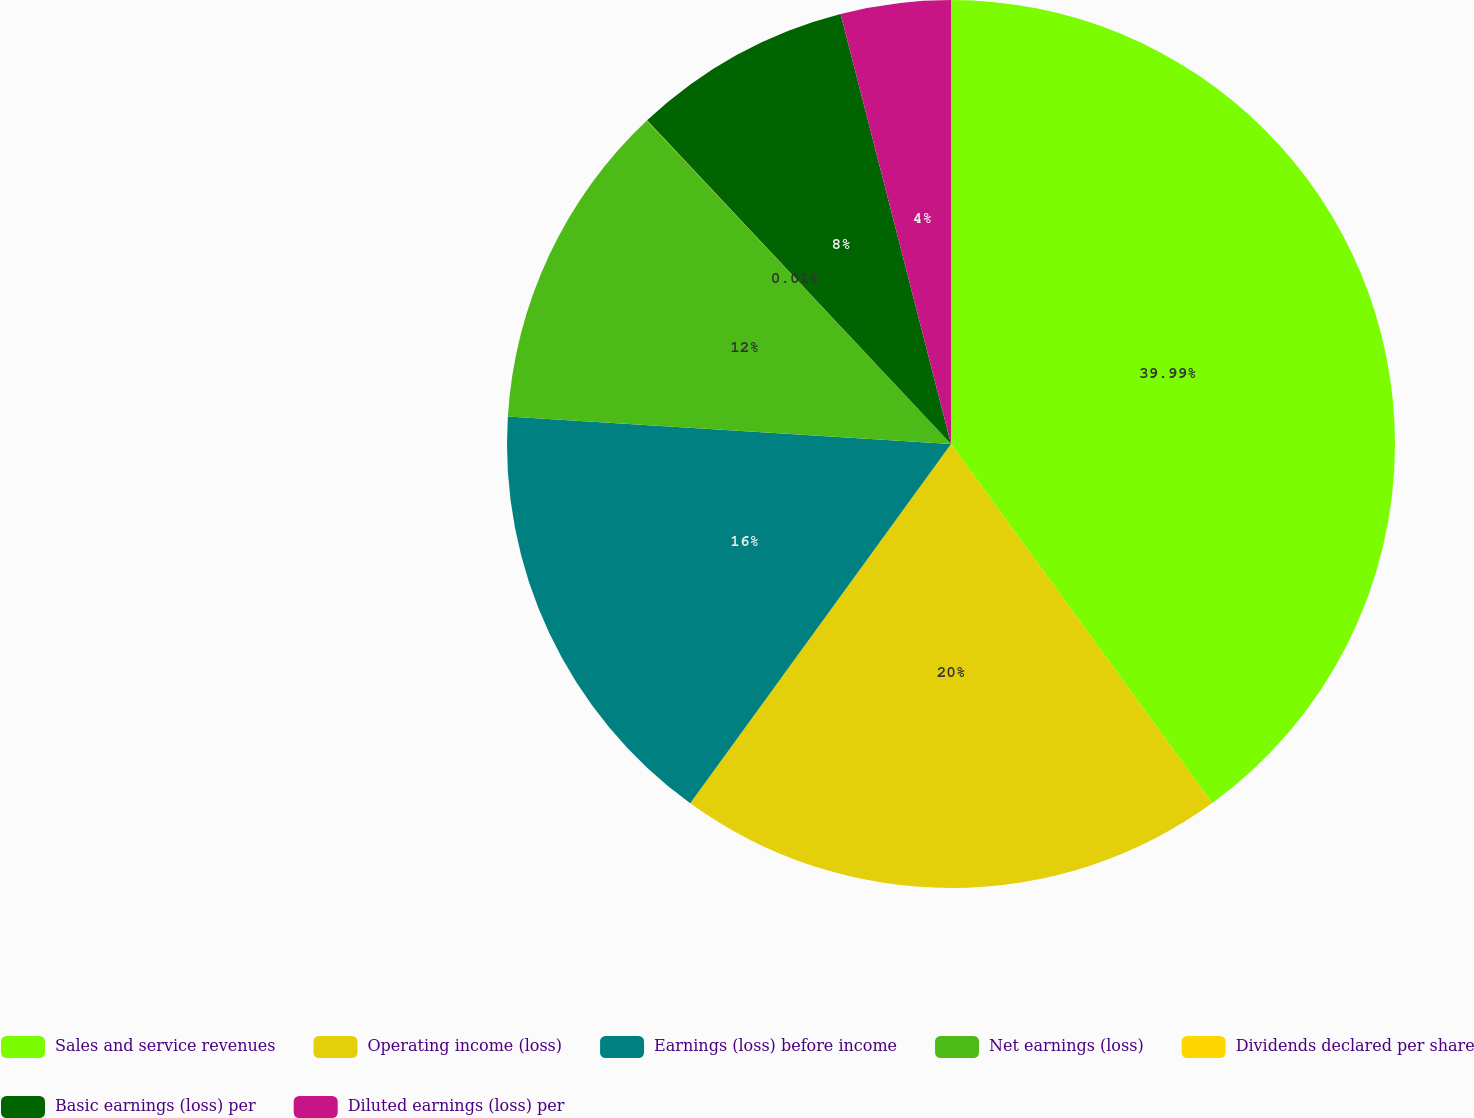Convert chart to OTSL. <chart><loc_0><loc_0><loc_500><loc_500><pie_chart><fcel>Sales and service revenues<fcel>Operating income (loss)<fcel>Earnings (loss) before income<fcel>Net earnings (loss)<fcel>Dividends declared per share<fcel>Basic earnings (loss) per<fcel>Diluted earnings (loss) per<nl><fcel>39.99%<fcel>20.0%<fcel>16.0%<fcel>12.0%<fcel>0.01%<fcel>8.0%<fcel>4.0%<nl></chart> 